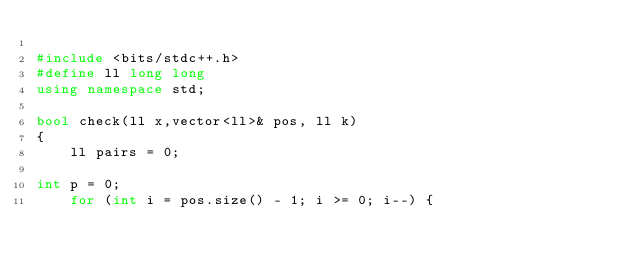Convert code to text. <code><loc_0><loc_0><loc_500><loc_500><_C++_>
#include <bits/stdc++.h>
#define ll long long
using namespace std;

bool check(ll x,vector<ll>& pos, ll k)
{
	ll pairs = 0;

int	p = 0;
	for (int i = pos.size() - 1; i >= 0; i--) {</code> 